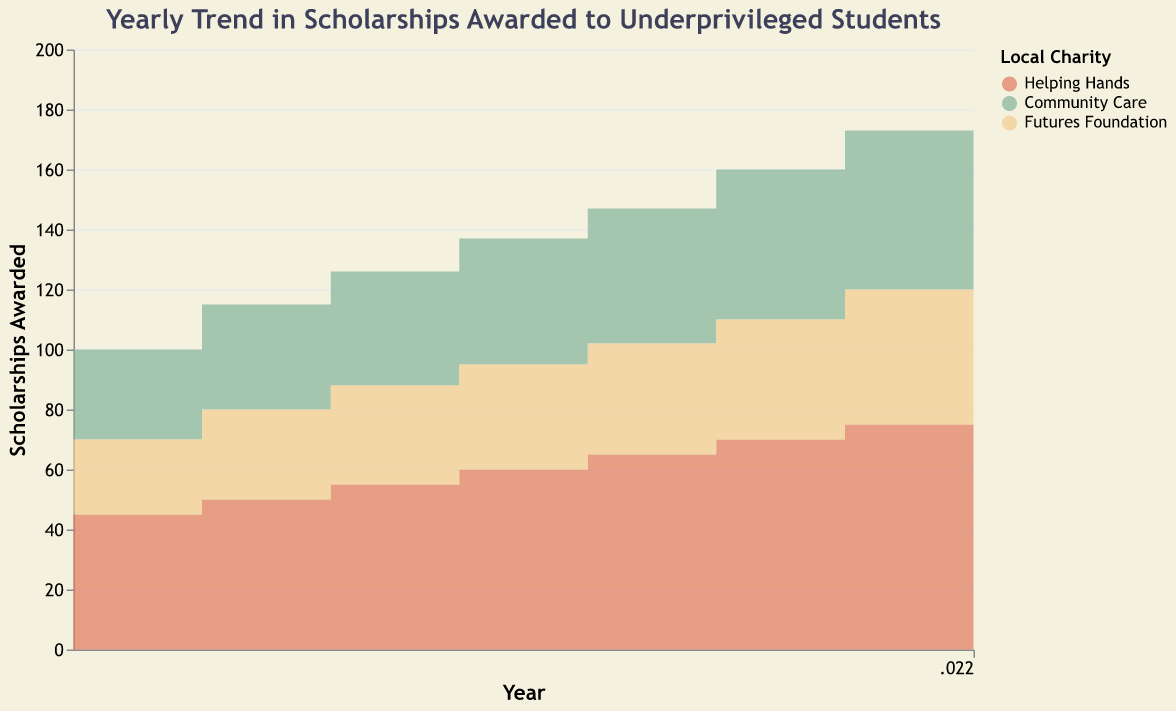What is the title of the figure? The title of the figure is displayed at the top and it reads "Yearly Trend in Scholarships Awarded to Underprivileged Students".
Answer: Yearly Trend in Scholarships Awarded to Underprivileged Students Which local charity awarded the most scholarships in 2018? By observing the steps for each color band corresponding to the charities, "Helping Hands" shows the highest step in 2018.
Answer: Helping Hands How many scholarships were awarded by "Community Care" in 2021? Look for the height of the "Community Care" color band for the year 2021 on the y-axis. It shows 53 scholarships.
Answer: 53 What trend can you observe for "Futures Foundation" from 2015 to 2022? Looking at the height of the color band representing "Futures Foundation" from left to right, it consistently increases year after year.
Answer: Consistent increase Compare the number of scholarships awarded by "Helping Hands" and "Community Care" in 2022. In 2022, "Helping Hands" awarded 80 scholarships, and "Community Care" awarded 60 scholarships. Compare these values.
Answer: 80 > 60 What was the total number of scholarships awarded across all charities in 2019? Sum the scholarships awarded by all three charities in 2019: Helping Hands (65) + Community Care (45) + Futures Foundation (37) = 147
Answer: 147 Between which two years did "Helping Hands" see the biggest increase in scholarships awarded? Compare the yearly differences in scholarships awarded by "Helping Hands": 2015 to 2016 (5), 2016 to 2017 (5), 2017 to 2018 (5), 2018 to 2019 (5), 2019 to 2020 (5), 2020 to 2021 (5), 2021 to 2022 (5). Each year shows an increase of 5 scholarships.
Answer: Each year is the same (5 scholarships/year) What is the color code used to represent "Community Care" in the figure? The color corresponding to "Community Care" in the legend is green.
Answer: green (81B29A) What's the average number of scholarships awarded per year by "Futures Foundation" from 2015 to 2022? Sum the scholarships awarded by "Futures Foundation" each year and divide by the number of years: (25 + 30 + 33 + 35 + 37 + 40 + 45 + 50) / 8 = 295 / 8 = 36.875
Answer: 36.875 